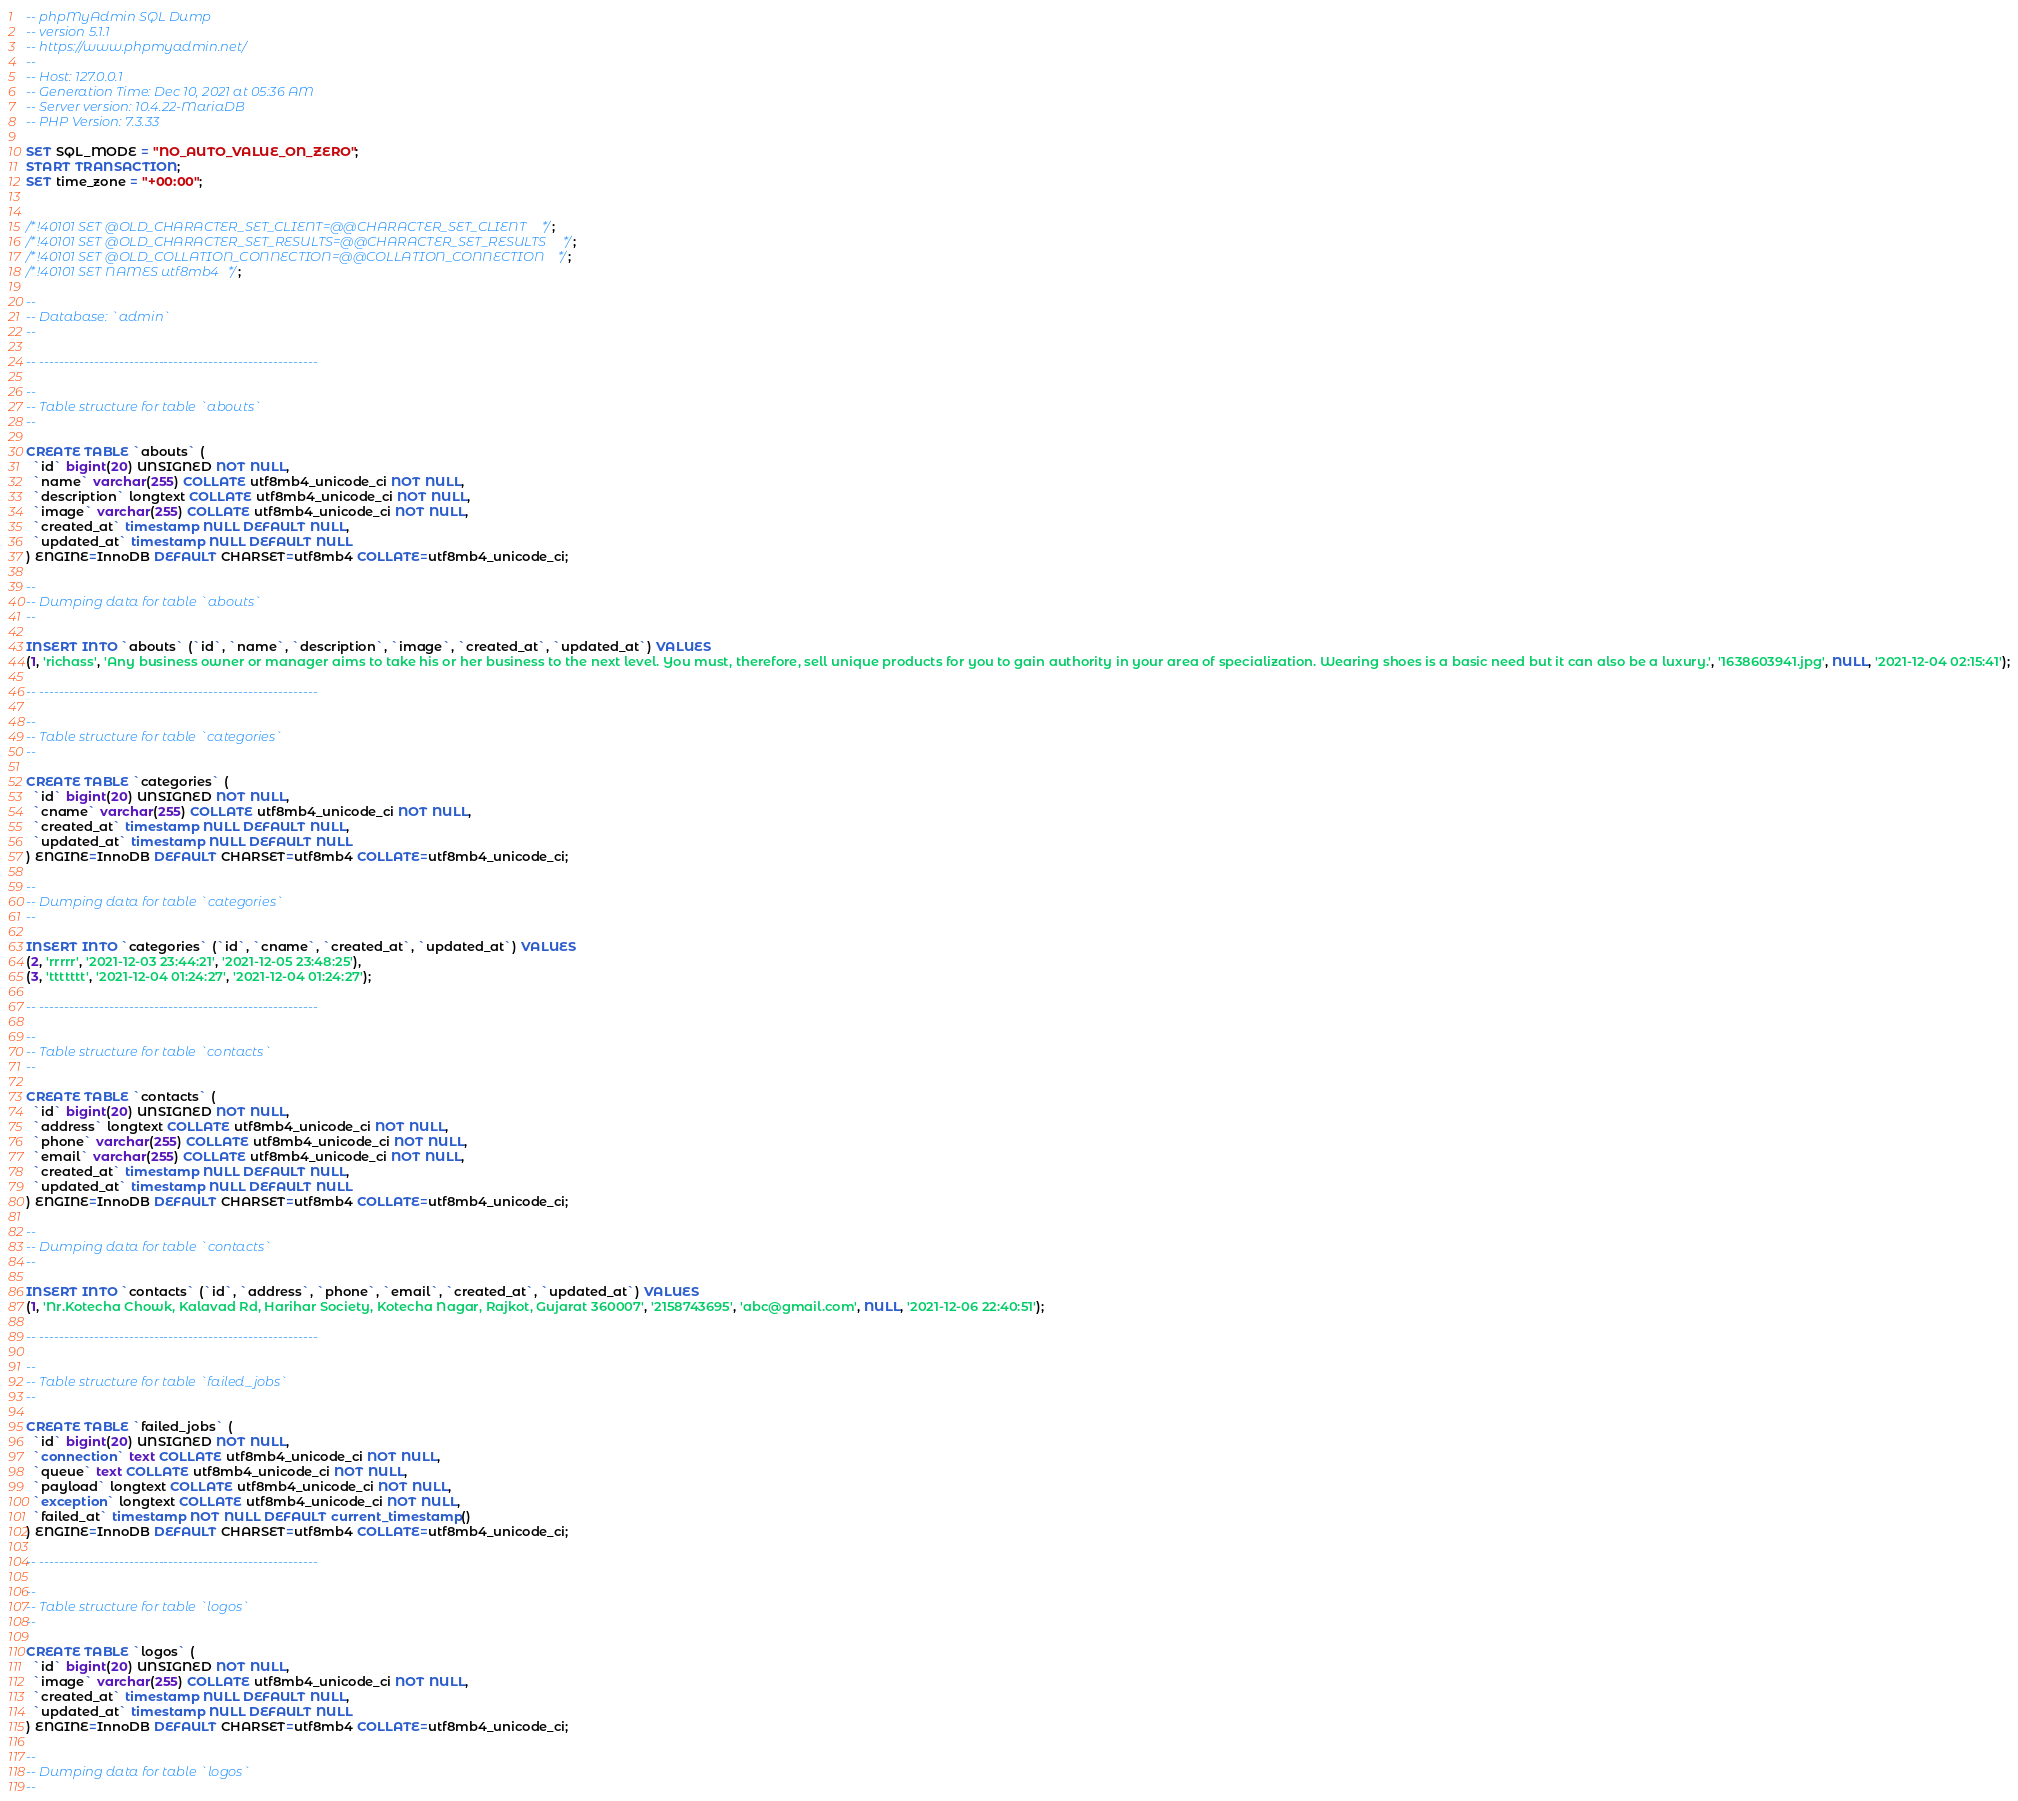Convert code to text. <code><loc_0><loc_0><loc_500><loc_500><_SQL_>-- phpMyAdmin SQL Dump
-- version 5.1.1
-- https://www.phpmyadmin.net/
--
-- Host: 127.0.0.1
-- Generation Time: Dec 10, 2021 at 05:36 AM
-- Server version: 10.4.22-MariaDB
-- PHP Version: 7.3.33

SET SQL_MODE = "NO_AUTO_VALUE_ON_ZERO";
START TRANSACTION;
SET time_zone = "+00:00";


/*!40101 SET @OLD_CHARACTER_SET_CLIENT=@@CHARACTER_SET_CLIENT */;
/*!40101 SET @OLD_CHARACTER_SET_RESULTS=@@CHARACTER_SET_RESULTS */;
/*!40101 SET @OLD_COLLATION_CONNECTION=@@COLLATION_CONNECTION */;
/*!40101 SET NAMES utf8mb4 */;

--
-- Database: `admin`
--

-- --------------------------------------------------------

--
-- Table structure for table `abouts`
--

CREATE TABLE `abouts` (
  `id` bigint(20) UNSIGNED NOT NULL,
  `name` varchar(255) COLLATE utf8mb4_unicode_ci NOT NULL,
  `description` longtext COLLATE utf8mb4_unicode_ci NOT NULL,
  `image` varchar(255) COLLATE utf8mb4_unicode_ci NOT NULL,
  `created_at` timestamp NULL DEFAULT NULL,
  `updated_at` timestamp NULL DEFAULT NULL
) ENGINE=InnoDB DEFAULT CHARSET=utf8mb4 COLLATE=utf8mb4_unicode_ci;

--
-- Dumping data for table `abouts`
--

INSERT INTO `abouts` (`id`, `name`, `description`, `image`, `created_at`, `updated_at`) VALUES
(1, 'richass', 'Any business owner or manager aims to take his or her business to the next level. You must, therefore, sell unique products for you to gain authority in your area of specialization. Wearing shoes is a basic need but it can also be a luxury.', '1638603941.jpg', NULL, '2021-12-04 02:15:41');

-- --------------------------------------------------------

--
-- Table structure for table `categories`
--

CREATE TABLE `categories` (
  `id` bigint(20) UNSIGNED NOT NULL,
  `cname` varchar(255) COLLATE utf8mb4_unicode_ci NOT NULL,
  `created_at` timestamp NULL DEFAULT NULL,
  `updated_at` timestamp NULL DEFAULT NULL
) ENGINE=InnoDB DEFAULT CHARSET=utf8mb4 COLLATE=utf8mb4_unicode_ci;

--
-- Dumping data for table `categories`
--

INSERT INTO `categories` (`id`, `cname`, `created_at`, `updated_at`) VALUES
(2, 'rrrrr', '2021-12-03 23:44:21', '2021-12-05 23:48:25'),
(3, 'ttttttt', '2021-12-04 01:24:27', '2021-12-04 01:24:27');

-- --------------------------------------------------------

--
-- Table structure for table `contacts`
--

CREATE TABLE `contacts` (
  `id` bigint(20) UNSIGNED NOT NULL,
  `address` longtext COLLATE utf8mb4_unicode_ci NOT NULL,
  `phone` varchar(255) COLLATE utf8mb4_unicode_ci NOT NULL,
  `email` varchar(255) COLLATE utf8mb4_unicode_ci NOT NULL,
  `created_at` timestamp NULL DEFAULT NULL,
  `updated_at` timestamp NULL DEFAULT NULL
) ENGINE=InnoDB DEFAULT CHARSET=utf8mb4 COLLATE=utf8mb4_unicode_ci;

--
-- Dumping data for table `contacts`
--

INSERT INTO `contacts` (`id`, `address`, `phone`, `email`, `created_at`, `updated_at`) VALUES
(1, 'Nr.Kotecha Chowk, Kalavad Rd, Harihar Society, Kotecha Nagar, Rajkot, Gujarat 360007', '2158743695', 'abc@gmail.com', NULL, '2021-12-06 22:40:51');

-- --------------------------------------------------------

--
-- Table structure for table `failed_jobs`
--

CREATE TABLE `failed_jobs` (
  `id` bigint(20) UNSIGNED NOT NULL,
  `connection` text COLLATE utf8mb4_unicode_ci NOT NULL,
  `queue` text COLLATE utf8mb4_unicode_ci NOT NULL,
  `payload` longtext COLLATE utf8mb4_unicode_ci NOT NULL,
  `exception` longtext COLLATE utf8mb4_unicode_ci NOT NULL,
  `failed_at` timestamp NOT NULL DEFAULT current_timestamp()
) ENGINE=InnoDB DEFAULT CHARSET=utf8mb4 COLLATE=utf8mb4_unicode_ci;

-- --------------------------------------------------------

--
-- Table structure for table `logos`
--

CREATE TABLE `logos` (
  `id` bigint(20) UNSIGNED NOT NULL,
  `image` varchar(255) COLLATE utf8mb4_unicode_ci NOT NULL,
  `created_at` timestamp NULL DEFAULT NULL,
  `updated_at` timestamp NULL DEFAULT NULL
) ENGINE=InnoDB DEFAULT CHARSET=utf8mb4 COLLATE=utf8mb4_unicode_ci;

--
-- Dumping data for table `logos`
--
</code> 